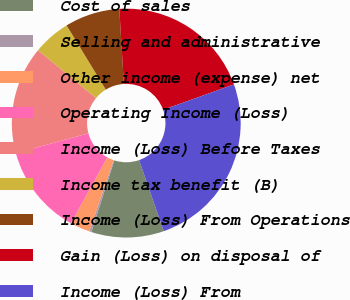Convert chart. <chart><loc_0><loc_0><loc_500><loc_500><pie_chart><fcel>Cost of sales<fcel>Selling and administrative<fcel>Other income (expense) net<fcel>Operating Income (Loss)<fcel>Income (Loss) Before Taxes<fcel>Income tax benefit (B)<fcel>Income (Loss) From Operations<fcel>Gain (Loss) on disposal of<fcel>Income (Loss) From<nl><fcel>10.25%<fcel>0.3%<fcel>2.79%<fcel>12.74%<fcel>15.22%<fcel>5.28%<fcel>7.76%<fcel>20.48%<fcel>25.17%<nl></chart> 